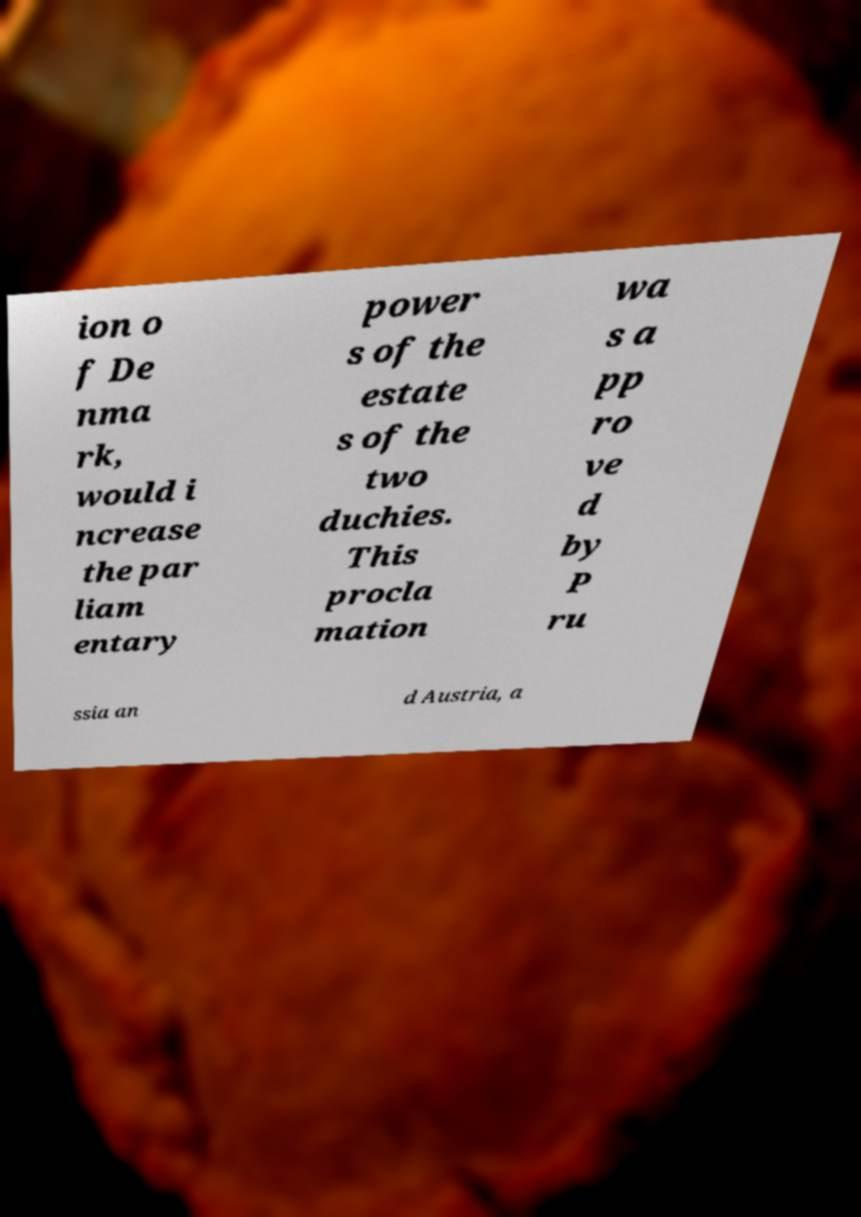Please read and relay the text visible in this image. What does it say? ion o f De nma rk, would i ncrease the par liam entary power s of the estate s of the two duchies. This procla mation wa s a pp ro ve d by P ru ssia an d Austria, a 